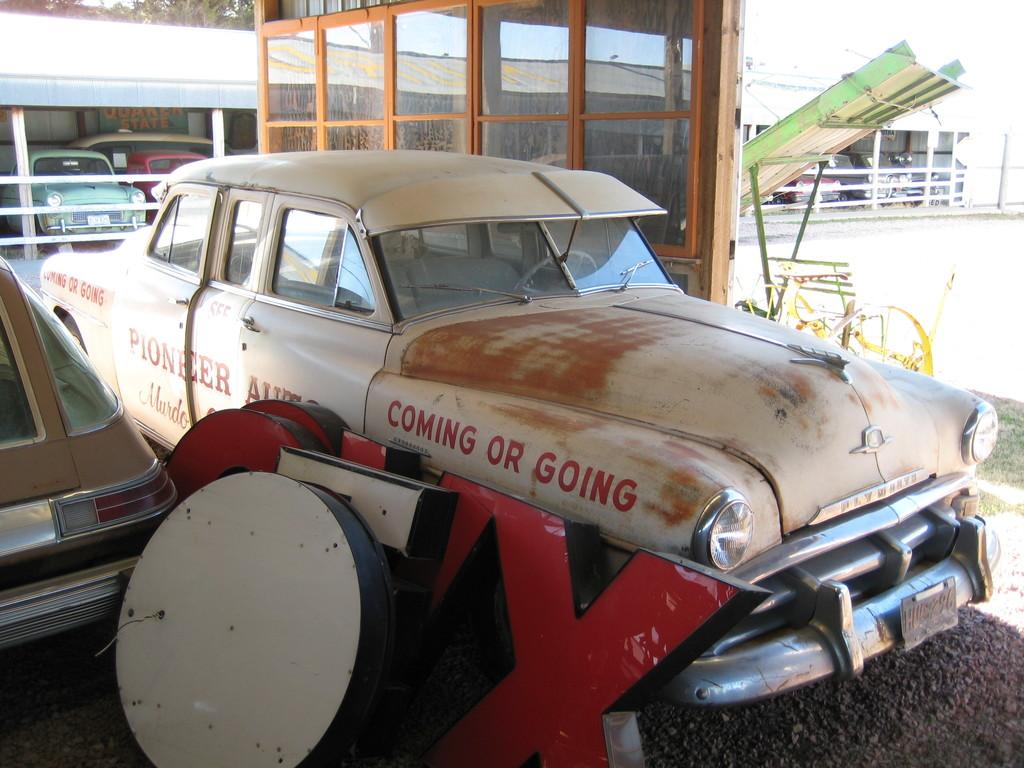Is that an old white plymouth ?
Offer a terse response. Yes. 